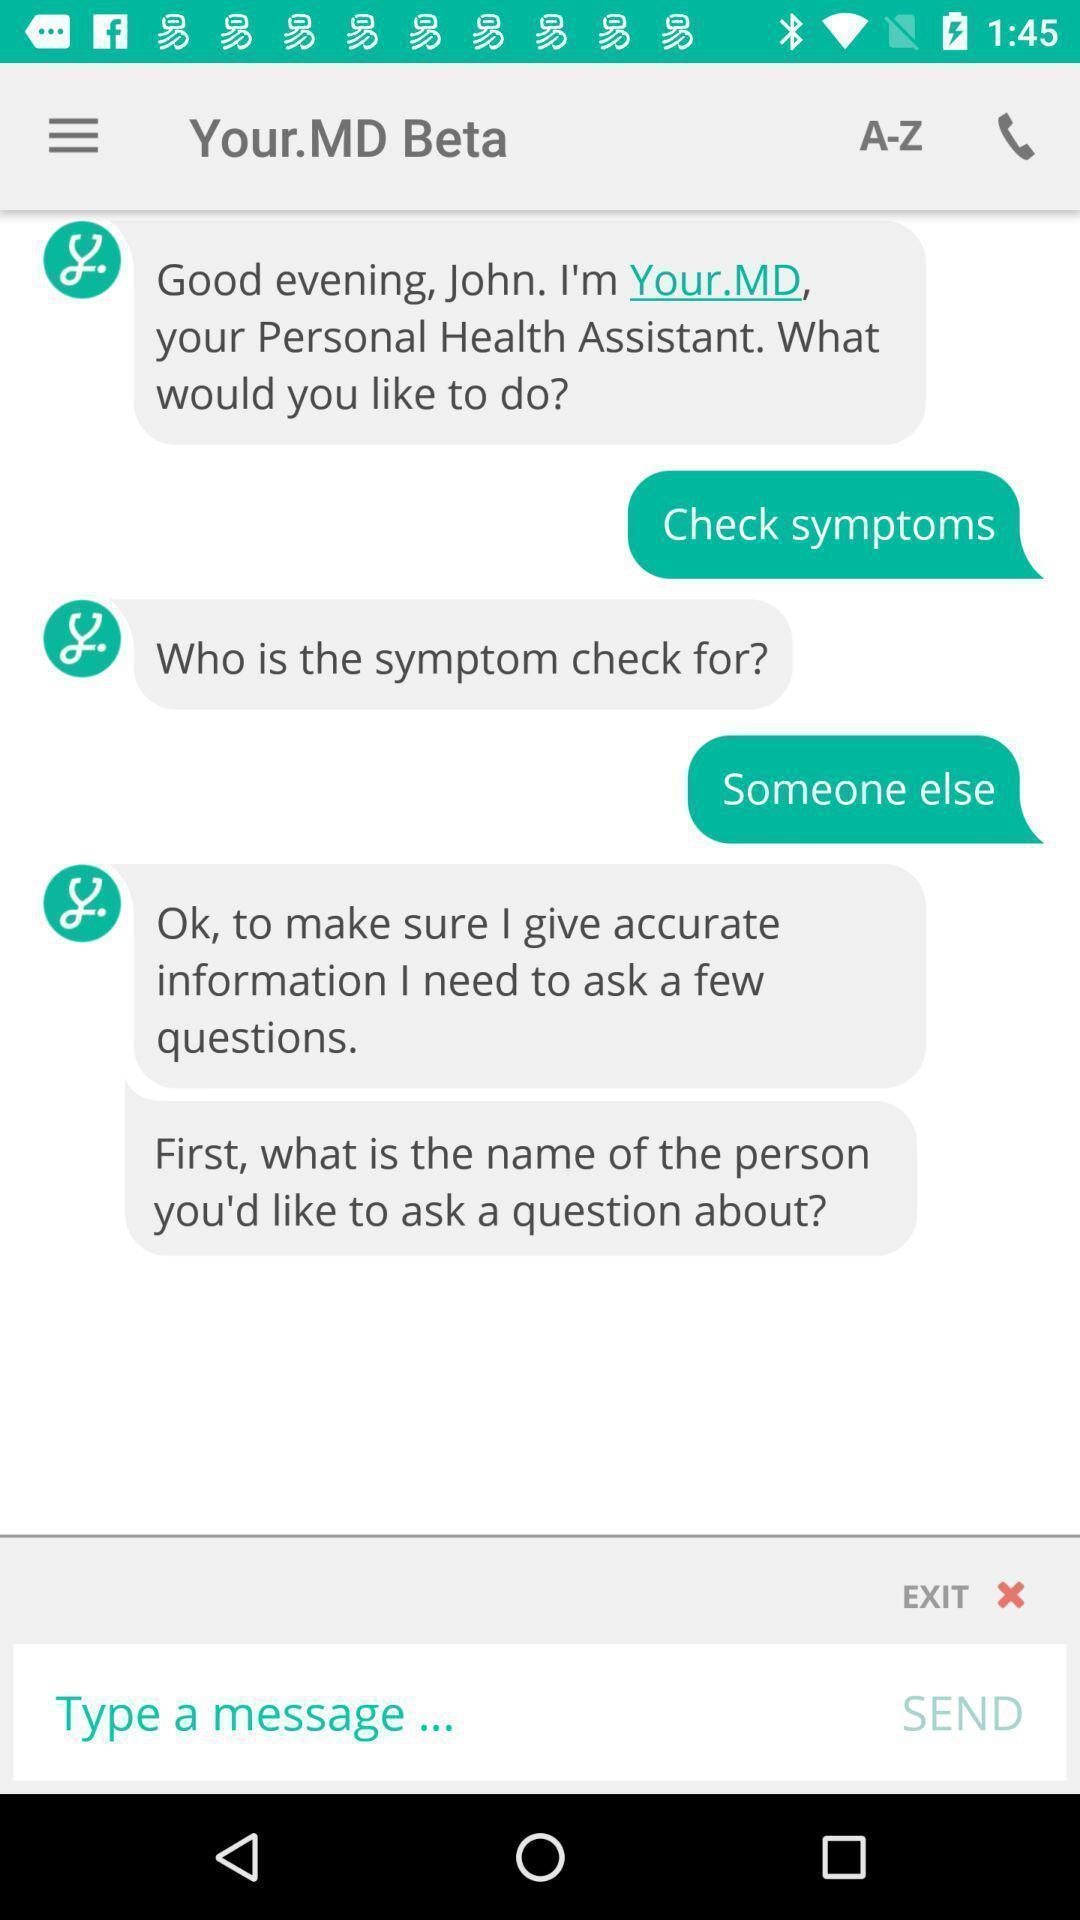Summarize the information in this screenshot. Screen shows conversation with a doctor. 